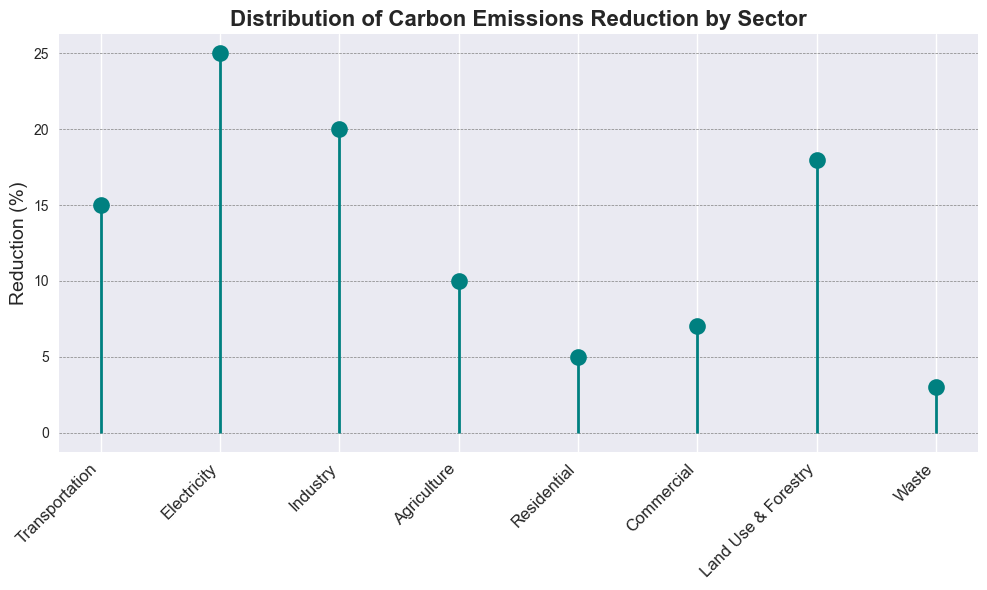What's the sector with the highest reduction in carbon emissions? Look at the highest point on the y-axis, then find the corresponding label on the x-axis. The highest reduction is 25%, corresponding to the Electricity sector.
Answer: Electricity Which sector has the lowest reduction percentage? Look at the lowest points on the y-axis and find the corresponding labels on the x-axis. The lowest reduction is 3%, which is associated with the Waste sector.
Answer: Waste How much more reduction does the Industry sector achieve compared to the Waste sector? Subtract the Waste sector's reduction percentage (3%) from the Industry sector's reduction percentage (20%). The difference is 20% - 3% = 17%.
Answer: 17% What is the total carbon emissions reduction for the Transportation, Residential, and Commercial sectors combined? Sum the reduction percentages for Transportation (15%), Residential (5%), and Commercial (7%). The total is 15% + 5% + 7% = 27%.
Answer: 27% Which sectors have reduction percentages greater than 15%? Identify sectors with reduction percentages above 15%. The sectors are Transportation, Electricity, Industry, and Land Use & Forestry with reductions of 15%, 25%, 20%, and 18% respectively.
Answer: Transportation, Electricity, Industry, Land Use & Forestry Is the reduction in the Agriculture sector more or less than the Residential sector? Compare the reductions: Agriculture is 10% while Residential is 5%. Agriculture has a higher reduction than Residential.
Answer: More What is the average reduction percentage across all sectors? Sum all the reduction percentages (15+25+20+10+5+7+18+3) and divide by the number of sectors (8). The sum is 103, hence the average is 103/8 = 12.875%.
Answer: 12.875% What is the combined reduction percentage for sectors classified as Industry, including Industry and Commercial? Sum the reduction percentages for Industry (20%) and Commercial (7%). The total reduction is 20% + 7% = 27%.
Answer: 27% What is the range of reduction percentages shown in the figure? Subtract the smallest reduction percentage (3% from Waste) from the largest reduction percentage (25% from Electricity). The range is 25% - 3% = 22%.
Answer: 22% How does the reduction percentage for Land Use & Forestry compare to the average reduction percentage across all sectors? First calculate the average reduction, which is 12.875%. Land Use & Forestry's reduction is 18%, which is greater than the average.
Answer: Greater 